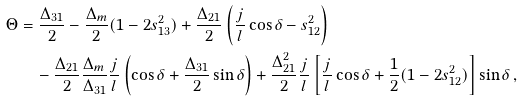Convert formula to latex. <formula><loc_0><loc_0><loc_500><loc_500>\Theta & = \frac { \Delta _ { 3 1 } } { 2 } - \frac { \Delta _ { m } } { 2 } ( 1 - 2 s _ { 1 3 } ^ { 2 } ) + \frac { \Delta _ { 2 1 } } { 2 } \left ( \frac { j } { l } \cos \delta - s _ { 1 2 } ^ { 2 } \right ) \\ & \quad - \frac { \Delta _ { 2 1 } } { 2 } \frac { \Delta _ { m } } { \Delta _ { 3 1 } } \frac { j } { l } \left ( \cos \delta + \frac { \Delta _ { 3 1 } } { 2 } \sin \delta \right ) + \frac { \Delta _ { 2 1 } ^ { 2 } } { 2 } \frac { j } { l } \left [ \frac { j } { l } \cos \delta + \frac { 1 } { 2 } ( 1 - 2 s _ { 1 2 } ^ { 2 } ) \right ] \sin \delta \, ,</formula> 